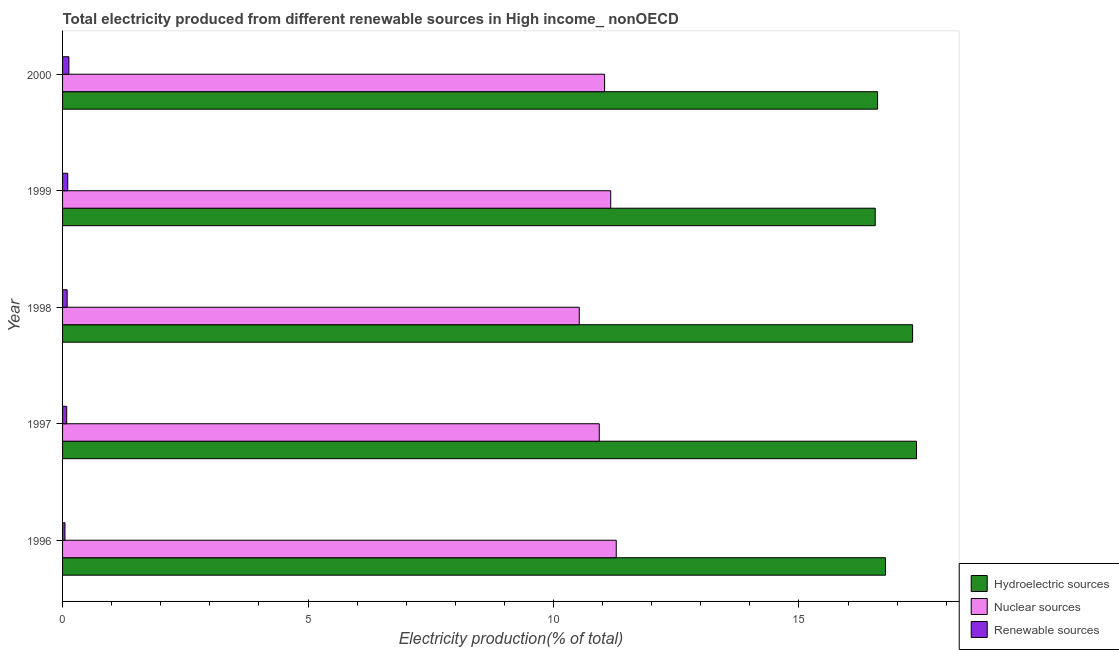Are the number of bars on each tick of the Y-axis equal?
Ensure brevity in your answer.  Yes. How many bars are there on the 5th tick from the top?
Your answer should be very brief. 3. How many bars are there on the 3rd tick from the bottom?
Give a very brief answer. 3. What is the label of the 4th group of bars from the top?
Your answer should be compact. 1997. In how many cases, is the number of bars for a given year not equal to the number of legend labels?
Your answer should be very brief. 0. What is the percentage of electricity produced by nuclear sources in 1998?
Your answer should be compact. 10.52. Across all years, what is the maximum percentage of electricity produced by nuclear sources?
Give a very brief answer. 11.28. Across all years, what is the minimum percentage of electricity produced by nuclear sources?
Your answer should be very brief. 10.52. In which year was the percentage of electricity produced by nuclear sources maximum?
Your answer should be compact. 1996. What is the total percentage of electricity produced by renewable sources in the graph?
Offer a very short reply. 0.46. What is the difference between the percentage of electricity produced by nuclear sources in 1998 and that in 2000?
Your response must be concise. -0.52. What is the difference between the percentage of electricity produced by renewable sources in 2000 and the percentage of electricity produced by nuclear sources in 1996?
Provide a succinct answer. -11.15. What is the average percentage of electricity produced by renewable sources per year?
Your answer should be compact. 0.09. In the year 1996, what is the difference between the percentage of electricity produced by renewable sources and percentage of electricity produced by nuclear sources?
Your answer should be compact. -11.23. What is the ratio of the percentage of electricity produced by renewable sources in 1998 to that in 2000?
Offer a very short reply. 0.73. Is the percentage of electricity produced by nuclear sources in 1996 less than that in 1999?
Provide a short and direct response. No. What is the difference between the highest and the second highest percentage of electricity produced by renewable sources?
Your answer should be compact. 0.02. What is the difference between the highest and the lowest percentage of electricity produced by hydroelectric sources?
Your answer should be very brief. 0.84. What does the 3rd bar from the top in 2000 represents?
Make the answer very short. Hydroelectric sources. What does the 3rd bar from the bottom in 1999 represents?
Your response must be concise. Renewable sources. How many bars are there?
Your response must be concise. 15. How many years are there in the graph?
Ensure brevity in your answer.  5. Are the values on the major ticks of X-axis written in scientific E-notation?
Make the answer very short. No. Does the graph contain any zero values?
Ensure brevity in your answer.  No. Does the graph contain grids?
Offer a terse response. No. Where does the legend appear in the graph?
Your answer should be compact. Bottom right. How many legend labels are there?
Your response must be concise. 3. How are the legend labels stacked?
Offer a terse response. Vertical. What is the title of the graph?
Ensure brevity in your answer.  Total electricity produced from different renewable sources in High income_ nonOECD. Does "Infant(male)" appear as one of the legend labels in the graph?
Ensure brevity in your answer.  No. What is the label or title of the Y-axis?
Make the answer very short. Year. What is the Electricity production(% of total) of Hydroelectric sources in 1996?
Your answer should be compact. 16.76. What is the Electricity production(% of total) of Nuclear sources in 1996?
Provide a succinct answer. 11.28. What is the Electricity production(% of total) in Renewable sources in 1996?
Your response must be concise. 0.05. What is the Electricity production(% of total) in Hydroelectric sources in 1997?
Offer a terse response. 17.39. What is the Electricity production(% of total) in Nuclear sources in 1997?
Provide a succinct answer. 10.93. What is the Electricity production(% of total) in Renewable sources in 1997?
Offer a terse response. 0.08. What is the Electricity production(% of total) of Hydroelectric sources in 1998?
Offer a terse response. 17.31. What is the Electricity production(% of total) in Nuclear sources in 1998?
Make the answer very short. 10.52. What is the Electricity production(% of total) in Renewable sources in 1998?
Ensure brevity in your answer.  0.09. What is the Electricity production(% of total) in Hydroelectric sources in 1999?
Provide a short and direct response. 16.55. What is the Electricity production(% of total) of Nuclear sources in 1999?
Provide a short and direct response. 11.17. What is the Electricity production(% of total) in Renewable sources in 1999?
Provide a short and direct response. 0.11. What is the Electricity production(% of total) in Hydroelectric sources in 2000?
Keep it short and to the point. 16.6. What is the Electricity production(% of total) in Nuclear sources in 2000?
Your answer should be very brief. 11.04. What is the Electricity production(% of total) in Renewable sources in 2000?
Offer a terse response. 0.13. Across all years, what is the maximum Electricity production(% of total) in Hydroelectric sources?
Your response must be concise. 17.39. Across all years, what is the maximum Electricity production(% of total) in Nuclear sources?
Make the answer very short. 11.28. Across all years, what is the maximum Electricity production(% of total) in Renewable sources?
Offer a very short reply. 0.13. Across all years, what is the minimum Electricity production(% of total) of Hydroelectric sources?
Make the answer very short. 16.55. Across all years, what is the minimum Electricity production(% of total) of Nuclear sources?
Your answer should be very brief. 10.52. Across all years, what is the minimum Electricity production(% of total) in Renewable sources?
Keep it short and to the point. 0.05. What is the total Electricity production(% of total) in Hydroelectric sources in the graph?
Provide a succinct answer. 84.62. What is the total Electricity production(% of total) in Nuclear sources in the graph?
Your answer should be compact. 54.94. What is the total Electricity production(% of total) of Renewable sources in the graph?
Provide a succinct answer. 0.46. What is the difference between the Electricity production(% of total) of Hydroelectric sources in 1996 and that in 1997?
Ensure brevity in your answer.  -0.63. What is the difference between the Electricity production(% of total) of Nuclear sources in 1996 and that in 1997?
Your answer should be compact. 0.35. What is the difference between the Electricity production(% of total) of Renewable sources in 1996 and that in 1997?
Provide a succinct answer. -0.04. What is the difference between the Electricity production(% of total) of Hydroelectric sources in 1996 and that in 1998?
Offer a very short reply. -0.55. What is the difference between the Electricity production(% of total) in Nuclear sources in 1996 and that in 1998?
Offer a terse response. 0.75. What is the difference between the Electricity production(% of total) in Renewable sources in 1996 and that in 1998?
Your answer should be compact. -0.04. What is the difference between the Electricity production(% of total) in Hydroelectric sources in 1996 and that in 1999?
Offer a terse response. 0.21. What is the difference between the Electricity production(% of total) of Nuclear sources in 1996 and that in 1999?
Offer a terse response. 0.11. What is the difference between the Electricity production(% of total) in Renewable sources in 1996 and that in 1999?
Provide a succinct answer. -0.06. What is the difference between the Electricity production(% of total) in Hydroelectric sources in 1996 and that in 2000?
Offer a terse response. 0.16. What is the difference between the Electricity production(% of total) in Nuclear sources in 1996 and that in 2000?
Offer a very short reply. 0.24. What is the difference between the Electricity production(% of total) in Renewable sources in 1996 and that in 2000?
Offer a very short reply. -0.08. What is the difference between the Electricity production(% of total) of Hydroelectric sources in 1997 and that in 1998?
Give a very brief answer. 0.08. What is the difference between the Electricity production(% of total) of Nuclear sources in 1997 and that in 1998?
Offer a very short reply. 0.41. What is the difference between the Electricity production(% of total) of Renewable sources in 1997 and that in 1998?
Offer a terse response. -0.01. What is the difference between the Electricity production(% of total) of Hydroelectric sources in 1997 and that in 1999?
Ensure brevity in your answer.  0.84. What is the difference between the Electricity production(% of total) in Nuclear sources in 1997 and that in 1999?
Ensure brevity in your answer.  -0.23. What is the difference between the Electricity production(% of total) in Renewable sources in 1997 and that in 1999?
Provide a short and direct response. -0.02. What is the difference between the Electricity production(% of total) of Hydroelectric sources in 1997 and that in 2000?
Provide a short and direct response. 0.79. What is the difference between the Electricity production(% of total) in Nuclear sources in 1997 and that in 2000?
Offer a terse response. -0.11. What is the difference between the Electricity production(% of total) of Renewable sources in 1997 and that in 2000?
Keep it short and to the point. -0.04. What is the difference between the Electricity production(% of total) in Hydroelectric sources in 1998 and that in 1999?
Your answer should be compact. 0.76. What is the difference between the Electricity production(% of total) in Nuclear sources in 1998 and that in 1999?
Offer a terse response. -0.64. What is the difference between the Electricity production(% of total) in Renewable sources in 1998 and that in 1999?
Offer a terse response. -0.01. What is the difference between the Electricity production(% of total) in Hydroelectric sources in 1998 and that in 2000?
Ensure brevity in your answer.  0.71. What is the difference between the Electricity production(% of total) in Nuclear sources in 1998 and that in 2000?
Your answer should be very brief. -0.52. What is the difference between the Electricity production(% of total) of Renewable sources in 1998 and that in 2000?
Make the answer very short. -0.03. What is the difference between the Electricity production(% of total) of Hydroelectric sources in 1999 and that in 2000?
Your answer should be very brief. -0.05. What is the difference between the Electricity production(% of total) of Nuclear sources in 1999 and that in 2000?
Your response must be concise. 0.12. What is the difference between the Electricity production(% of total) in Renewable sources in 1999 and that in 2000?
Offer a very short reply. -0.02. What is the difference between the Electricity production(% of total) of Hydroelectric sources in 1996 and the Electricity production(% of total) of Nuclear sources in 1997?
Your answer should be very brief. 5.83. What is the difference between the Electricity production(% of total) in Hydroelectric sources in 1996 and the Electricity production(% of total) in Renewable sources in 1997?
Keep it short and to the point. 16.68. What is the difference between the Electricity production(% of total) in Nuclear sources in 1996 and the Electricity production(% of total) in Renewable sources in 1997?
Your answer should be very brief. 11.19. What is the difference between the Electricity production(% of total) in Hydroelectric sources in 1996 and the Electricity production(% of total) in Nuclear sources in 1998?
Ensure brevity in your answer.  6.24. What is the difference between the Electricity production(% of total) in Hydroelectric sources in 1996 and the Electricity production(% of total) in Renewable sources in 1998?
Provide a succinct answer. 16.67. What is the difference between the Electricity production(% of total) in Nuclear sources in 1996 and the Electricity production(% of total) in Renewable sources in 1998?
Your answer should be compact. 11.18. What is the difference between the Electricity production(% of total) in Hydroelectric sources in 1996 and the Electricity production(% of total) in Nuclear sources in 1999?
Ensure brevity in your answer.  5.6. What is the difference between the Electricity production(% of total) of Hydroelectric sources in 1996 and the Electricity production(% of total) of Renewable sources in 1999?
Your answer should be compact. 16.66. What is the difference between the Electricity production(% of total) of Nuclear sources in 1996 and the Electricity production(% of total) of Renewable sources in 1999?
Ensure brevity in your answer.  11.17. What is the difference between the Electricity production(% of total) of Hydroelectric sources in 1996 and the Electricity production(% of total) of Nuclear sources in 2000?
Ensure brevity in your answer.  5.72. What is the difference between the Electricity production(% of total) in Hydroelectric sources in 1996 and the Electricity production(% of total) in Renewable sources in 2000?
Offer a terse response. 16.63. What is the difference between the Electricity production(% of total) in Nuclear sources in 1996 and the Electricity production(% of total) in Renewable sources in 2000?
Keep it short and to the point. 11.15. What is the difference between the Electricity production(% of total) in Hydroelectric sources in 1997 and the Electricity production(% of total) in Nuclear sources in 1998?
Provide a short and direct response. 6.87. What is the difference between the Electricity production(% of total) of Hydroelectric sources in 1997 and the Electricity production(% of total) of Renewable sources in 1998?
Offer a terse response. 17.3. What is the difference between the Electricity production(% of total) of Nuclear sources in 1997 and the Electricity production(% of total) of Renewable sources in 1998?
Your response must be concise. 10.84. What is the difference between the Electricity production(% of total) of Hydroelectric sources in 1997 and the Electricity production(% of total) of Nuclear sources in 1999?
Give a very brief answer. 6.23. What is the difference between the Electricity production(% of total) in Hydroelectric sources in 1997 and the Electricity production(% of total) in Renewable sources in 1999?
Provide a short and direct response. 17.29. What is the difference between the Electricity production(% of total) of Nuclear sources in 1997 and the Electricity production(% of total) of Renewable sources in 1999?
Ensure brevity in your answer.  10.83. What is the difference between the Electricity production(% of total) in Hydroelectric sources in 1997 and the Electricity production(% of total) in Nuclear sources in 2000?
Your response must be concise. 6.35. What is the difference between the Electricity production(% of total) in Hydroelectric sources in 1997 and the Electricity production(% of total) in Renewable sources in 2000?
Your response must be concise. 17.27. What is the difference between the Electricity production(% of total) of Nuclear sources in 1997 and the Electricity production(% of total) of Renewable sources in 2000?
Provide a short and direct response. 10.8. What is the difference between the Electricity production(% of total) in Hydroelectric sources in 1998 and the Electricity production(% of total) in Nuclear sources in 1999?
Your answer should be very brief. 6.15. What is the difference between the Electricity production(% of total) in Hydroelectric sources in 1998 and the Electricity production(% of total) in Renewable sources in 1999?
Your answer should be very brief. 17.21. What is the difference between the Electricity production(% of total) in Nuclear sources in 1998 and the Electricity production(% of total) in Renewable sources in 1999?
Provide a short and direct response. 10.42. What is the difference between the Electricity production(% of total) of Hydroelectric sources in 1998 and the Electricity production(% of total) of Nuclear sources in 2000?
Provide a succinct answer. 6.27. What is the difference between the Electricity production(% of total) of Hydroelectric sources in 1998 and the Electricity production(% of total) of Renewable sources in 2000?
Your response must be concise. 17.19. What is the difference between the Electricity production(% of total) in Nuclear sources in 1998 and the Electricity production(% of total) in Renewable sources in 2000?
Make the answer very short. 10.4. What is the difference between the Electricity production(% of total) in Hydroelectric sources in 1999 and the Electricity production(% of total) in Nuclear sources in 2000?
Your response must be concise. 5.51. What is the difference between the Electricity production(% of total) of Hydroelectric sources in 1999 and the Electricity production(% of total) of Renewable sources in 2000?
Give a very brief answer. 16.42. What is the difference between the Electricity production(% of total) of Nuclear sources in 1999 and the Electricity production(% of total) of Renewable sources in 2000?
Provide a succinct answer. 11.04. What is the average Electricity production(% of total) in Hydroelectric sources per year?
Keep it short and to the point. 16.92. What is the average Electricity production(% of total) in Nuclear sources per year?
Your answer should be compact. 10.99. What is the average Electricity production(% of total) in Renewable sources per year?
Give a very brief answer. 0.09. In the year 1996, what is the difference between the Electricity production(% of total) of Hydroelectric sources and Electricity production(% of total) of Nuclear sources?
Your answer should be compact. 5.48. In the year 1996, what is the difference between the Electricity production(% of total) in Hydroelectric sources and Electricity production(% of total) in Renewable sources?
Provide a succinct answer. 16.71. In the year 1996, what is the difference between the Electricity production(% of total) of Nuclear sources and Electricity production(% of total) of Renewable sources?
Give a very brief answer. 11.23. In the year 1997, what is the difference between the Electricity production(% of total) of Hydroelectric sources and Electricity production(% of total) of Nuclear sources?
Provide a succinct answer. 6.46. In the year 1997, what is the difference between the Electricity production(% of total) of Hydroelectric sources and Electricity production(% of total) of Renewable sources?
Your answer should be compact. 17.31. In the year 1997, what is the difference between the Electricity production(% of total) of Nuclear sources and Electricity production(% of total) of Renewable sources?
Your answer should be very brief. 10.85. In the year 1998, what is the difference between the Electricity production(% of total) of Hydroelectric sources and Electricity production(% of total) of Nuclear sources?
Offer a very short reply. 6.79. In the year 1998, what is the difference between the Electricity production(% of total) of Hydroelectric sources and Electricity production(% of total) of Renewable sources?
Provide a short and direct response. 17.22. In the year 1998, what is the difference between the Electricity production(% of total) of Nuclear sources and Electricity production(% of total) of Renewable sources?
Offer a terse response. 10.43. In the year 1999, what is the difference between the Electricity production(% of total) of Hydroelectric sources and Electricity production(% of total) of Nuclear sources?
Provide a succinct answer. 5.39. In the year 1999, what is the difference between the Electricity production(% of total) of Hydroelectric sources and Electricity production(% of total) of Renewable sources?
Provide a succinct answer. 16.45. In the year 1999, what is the difference between the Electricity production(% of total) in Nuclear sources and Electricity production(% of total) in Renewable sources?
Keep it short and to the point. 11.06. In the year 2000, what is the difference between the Electricity production(% of total) in Hydroelectric sources and Electricity production(% of total) in Nuclear sources?
Offer a very short reply. 5.56. In the year 2000, what is the difference between the Electricity production(% of total) of Hydroelectric sources and Electricity production(% of total) of Renewable sources?
Offer a terse response. 16.47. In the year 2000, what is the difference between the Electricity production(% of total) in Nuclear sources and Electricity production(% of total) in Renewable sources?
Provide a succinct answer. 10.91. What is the ratio of the Electricity production(% of total) of Hydroelectric sources in 1996 to that in 1997?
Your response must be concise. 0.96. What is the ratio of the Electricity production(% of total) of Nuclear sources in 1996 to that in 1997?
Give a very brief answer. 1.03. What is the ratio of the Electricity production(% of total) in Renewable sources in 1996 to that in 1997?
Ensure brevity in your answer.  0.58. What is the ratio of the Electricity production(% of total) of Hydroelectric sources in 1996 to that in 1998?
Give a very brief answer. 0.97. What is the ratio of the Electricity production(% of total) of Nuclear sources in 1996 to that in 1998?
Provide a short and direct response. 1.07. What is the ratio of the Electricity production(% of total) of Renewable sources in 1996 to that in 1998?
Offer a very short reply. 0.52. What is the ratio of the Electricity production(% of total) of Hydroelectric sources in 1996 to that in 1999?
Ensure brevity in your answer.  1.01. What is the ratio of the Electricity production(% of total) in Renewable sources in 1996 to that in 1999?
Ensure brevity in your answer.  0.47. What is the ratio of the Electricity production(% of total) in Hydroelectric sources in 1996 to that in 2000?
Provide a succinct answer. 1.01. What is the ratio of the Electricity production(% of total) in Nuclear sources in 1996 to that in 2000?
Your response must be concise. 1.02. What is the ratio of the Electricity production(% of total) of Renewable sources in 1996 to that in 2000?
Provide a short and direct response. 0.38. What is the ratio of the Electricity production(% of total) of Hydroelectric sources in 1997 to that in 1998?
Provide a short and direct response. 1. What is the ratio of the Electricity production(% of total) of Nuclear sources in 1997 to that in 1998?
Keep it short and to the point. 1.04. What is the ratio of the Electricity production(% of total) of Hydroelectric sources in 1997 to that in 1999?
Your answer should be very brief. 1.05. What is the ratio of the Electricity production(% of total) in Nuclear sources in 1997 to that in 1999?
Give a very brief answer. 0.98. What is the ratio of the Electricity production(% of total) in Renewable sources in 1997 to that in 1999?
Your answer should be very brief. 0.8. What is the ratio of the Electricity production(% of total) in Hydroelectric sources in 1997 to that in 2000?
Make the answer very short. 1.05. What is the ratio of the Electricity production(% of total) of Nuclear sources in 1997 to that in 2000?
Provide a succinct answer. 0.99. What is the ratio of the Electricity production(% of total) in Renewable sources in 1997 to that in 2000?
Provide a short and direct response. 0.66. What is the ratio of the Electricity production(% of total) in Hydroelectric sources in 1998 to that in 1999?
Provide a succinct answer. 1.05. What is the ratio of the Electricity production(% of total) in Nuclear sources in 1998 to that in 1999?
Provide a succinct answer. 0.94. What is the ratio of the Electricity production(% of total) in Renewable sources in 1998 to that in 1999?
Ensure brevity in your answer.  0.89. What is the ratio of the Electricity production(% of total) of Hydroelectric sources in 1998 to that in 2000?
Give a very brief answer. 1.04. What is the ratio of the Electricity production(% of total) of Nuclear sources in 1998 to that in 2000?
Offer a terse response. 0.95. What is the ratio of the Electricity production(% of total) in Renewable sources in 1998 to that in 2000?
Give a very brief answer. 0.73. What is the ratio of the Electricity production(% of total) in Hydroelectric sources in 1999 to that in 2000?
Provide a short and direct response. 1. What is the ratio of the Electricity production(% of total) in Nuclear sources in 1999 to that in 2000?
Provide a succinct answer. 1.01. What is the ratio of the Electricity production(% of total) in Renewable sources in 1999 to that in 2000?
Your response must be concise. 0.82. What is the difference between the highest and the second highest Electricity production(% of total) of Hydroelectric sources?
Give a very brief answer. 0.08. What is the difference between the highest and the second highest Electricity production(% of total) in Nuclear sources?
Make the answer very short. 0.11. What is the difference between the highest and the second highest Electricity production(% of total) in Renewable sources?
Ensure brevity in your answer.  0.02. What is the difference between the highest and the lowest Electricity production(% of total) in Hydroelectric sources?
Your response must be concise. 0.84. What is the difference between the highest and the lowest Electricity production(% of total) of Nuclear sources?
Provide a short and direct response. 0.75. What is the difference between the highest and the lowest Electricity production(% of total) of Renewable sources?
Give a very brief answer. 0.08. 